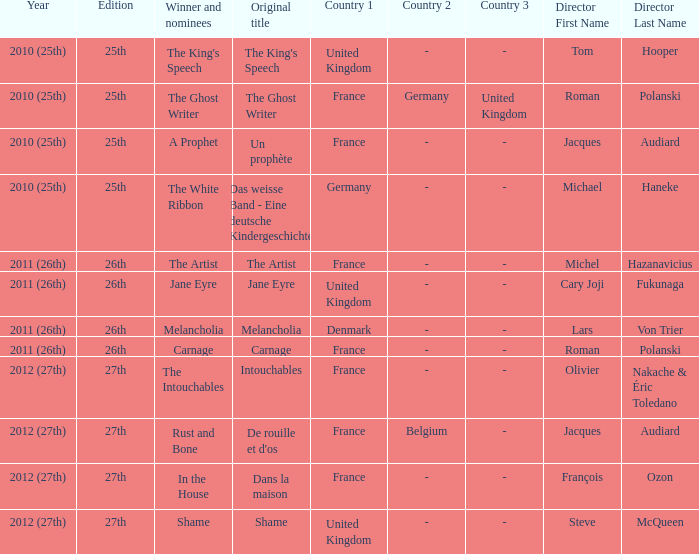Who was the winner and nominees for the movie directed by cary joji fukunaga? Jane Eyre. 